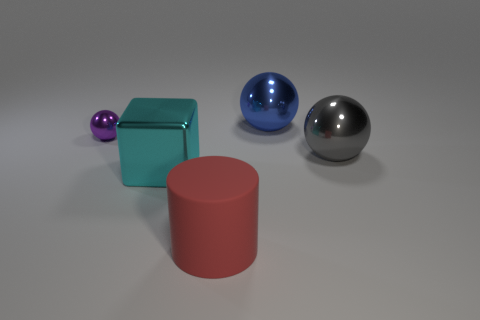How many other things are the same size as the purple shiny sphere?
Provide a succinct answer. 0. The big sphere that is on the left side of the big metal object that is on the right side of the big sphere that is on the left side of the gray object is made of what material?
Offer a terse response. Metal. What number of balls are either big gray objects or purple things?
Keep it short and to the point. 2. Are there any other things that are the same shape as the cyan shiny object?
Make the answer very short. No. Is the number of large objects to the right of the small metal thing greater than the number of cubes on the right side of the gray object?
Provide a short and direct response. Yes. How many gray metallic spheres are in front of the sphere to the left of the large cyan block?
Keep it short and to the point. 1. What number of objects are either purple metallic balls or big blue rubber blocks?
Offer a terse response. 1. Is the shape of the blue thing the same as the rubber object?
Ensure brevity in your answer.  No. What is the material of the blue ball?
Provide a succinct answer. Metal. How many shiny objects are both left of the gray metallic ball and on the right side of the tiny metal object?
Keep it short and to the point. 2. 